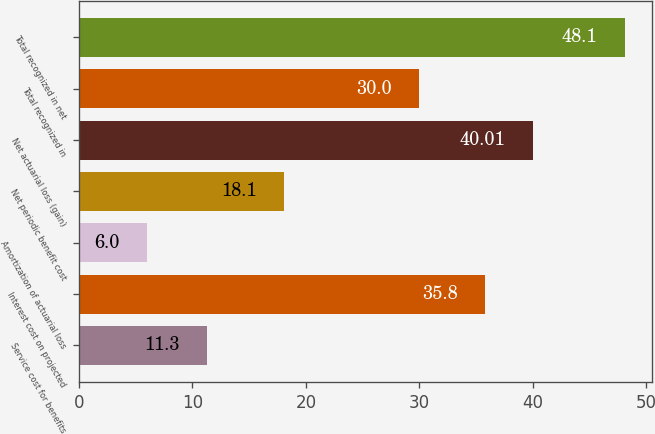Convert chart to OTSL. <chart><loc_0><loc_0><loc_500><loc_500><bar_chart><fcel>Service cost for benefits<fcel>Interest cost on projected<fcel>Amortization of actuarial loss<fcel>Net periodic benefit cost<fcel>Net actuarial loss (gain)<fcel>Total recognized in<fcel>Total recognized in net<nl><fcel>11.3<fcel>35.8<fcel>6<fcel>18.1<fcel>40.01<fcel>30<fcel>48.1<nl></chart> 